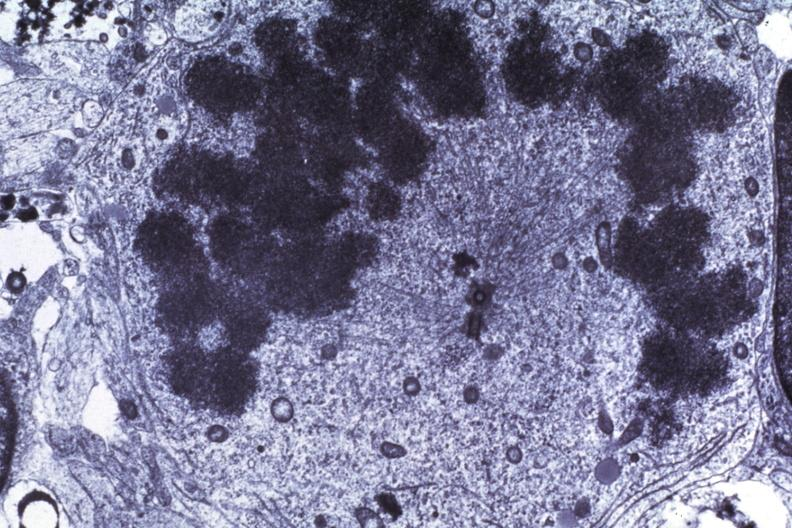s brain present?
Answer the question using a single word or phrase. Yes 